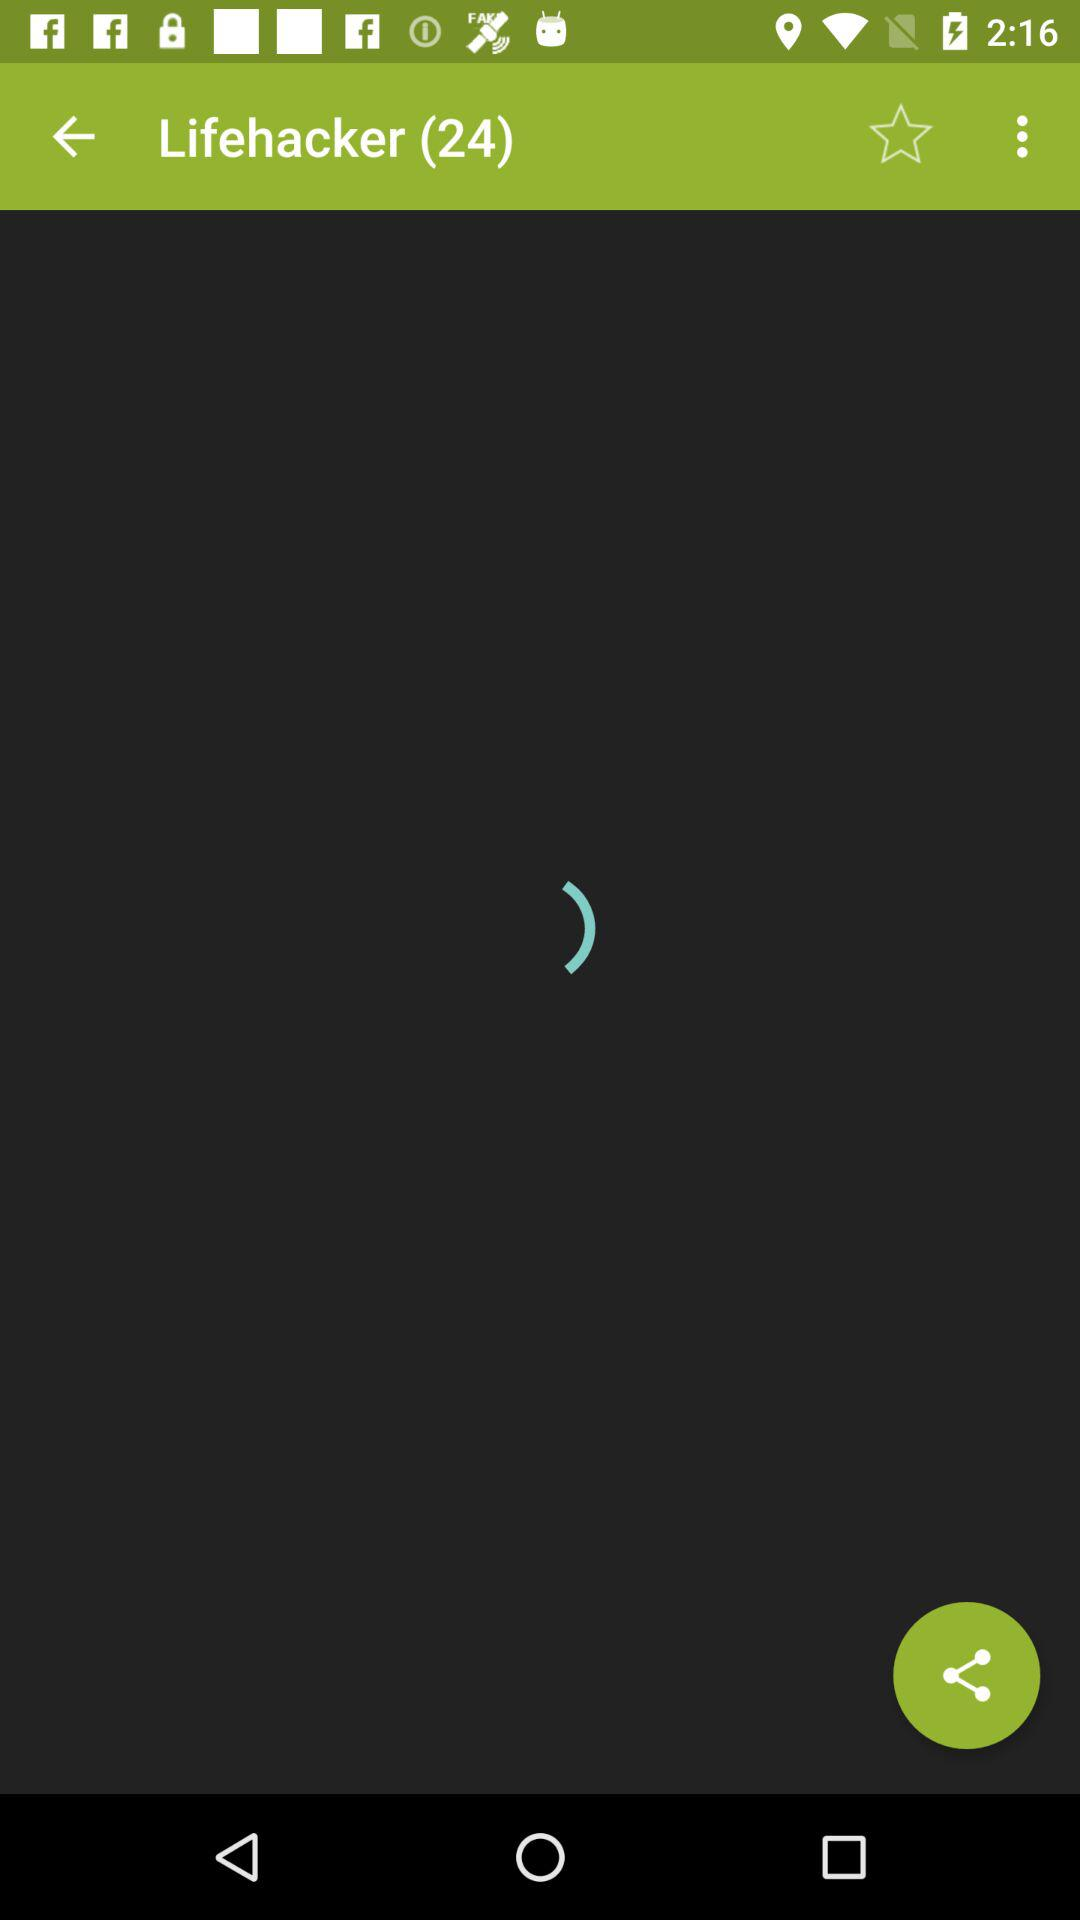What are the names of the listed items?
When the provided information is insufficient, respond with <no answer>. <no answer> 